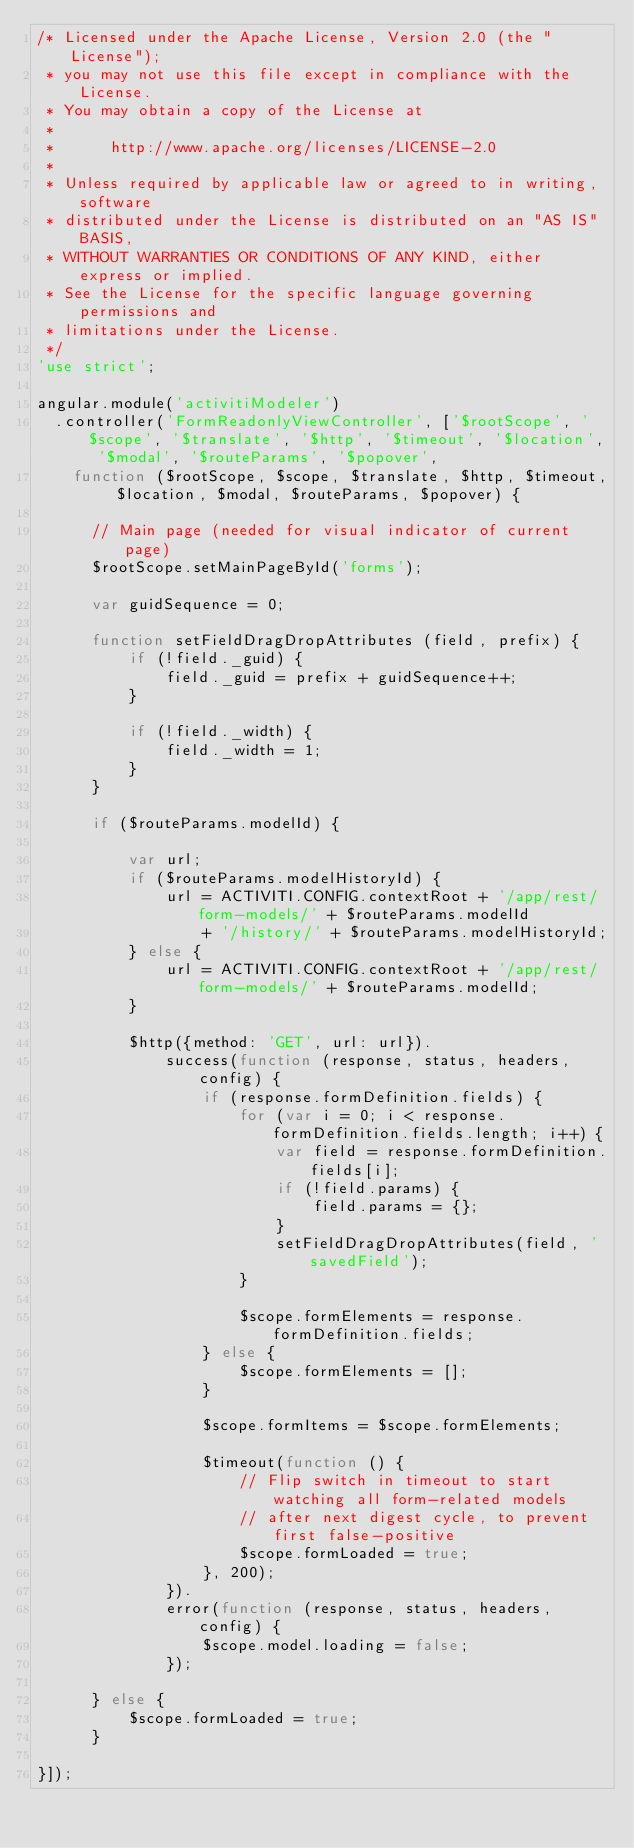<code> <loc_0><loc_0><loc_500><loc_500><_JavaScript_>/* Licensed under the Apache License, Version 2.0 (the "License");
 * you may not use this file except in compliance with the License.
 * You may obtain a copy of the License at
 *
 *      http://www.apache.org/licenses/LICENSE-2.0
 *
 * Unless required by applicable law or agreed to in writing, software
 * distributed under the License is distributed on an "AS IS" BASIS,
 * WITHOUT WARRANTIES OR CONDITIONS OF ANY KIND, either express or implied.
 * See the License for the specific language governing permissions and
 * limitations under the License.
 */
'use strict';

angular.module('activitiModeler')
  .controller('FormReadonlyViewController', ['$rootScope', '$scope', '$translate', '$http', '$timeout', '$location', '$modal', '$routeParams', '$popover',
    function ($rootScope, $scope, $translate, $http, $timeout, $location, $modal, $routeParams, $popover) {

      // Main page (needed for visual indicator of current page)
      $rootScope.setMainPageById('forms');
      
      var guidSequence = 0;
      
      function setFieldDragDropAttributes (field, prefix) {
          if (!field._guid) {
              field._guid = prefix + guidSequence++;
          }
          
          if (!field._width) {
              field._width = 1;
          }
      }

      if ($routeParams.modelId) {

          var url;
          if ($routeParams.modelHistoryId) {
              url = ACTIVITI.CONFIG.contextRoot + '/app/rest/form-models/' + $routeParams.modelId
                  + '/history/' + $routeParams.modelHistoryId;
          } else {
              url = ACTIVITI.CONFIG.contextRoot + '/app/rest/form-models/' + $routeParams.modelId;
          }

          $http({method: 'GET', url: url}).
              success(function (response, status, headers, config) {
                  if (response.formDefinition.fields) {
                      for (var i = 0; i < response.formDefinition.fields.length; i++) {
                          var field = response.formDefinition.fields[i];
                          if (!field.params) {
                              field.params = {};
                          }
                          setFieldDragDropAttributes(field, 'savedField');
                      }

                      $scope.formElements = response.formDefinition.fields;
                  } else {
                      $scope.formElements = [];
                  }
            
                  $scope.formItems = $scope.formElements;
                  
                  $timeout(function () {
                      // Flip switch in timeout to start watching all form-related models
                      // after next digest cycle, to prevent first false-positive
                      $scope.formLoaded = true;
                  }, 200);
              }).
              error(function (response, status, headers, config) {
                  $scope.model.loading = false;
              });
          
      } else {
          $scope.formLoaded = true;
      }

}]);
</code> 